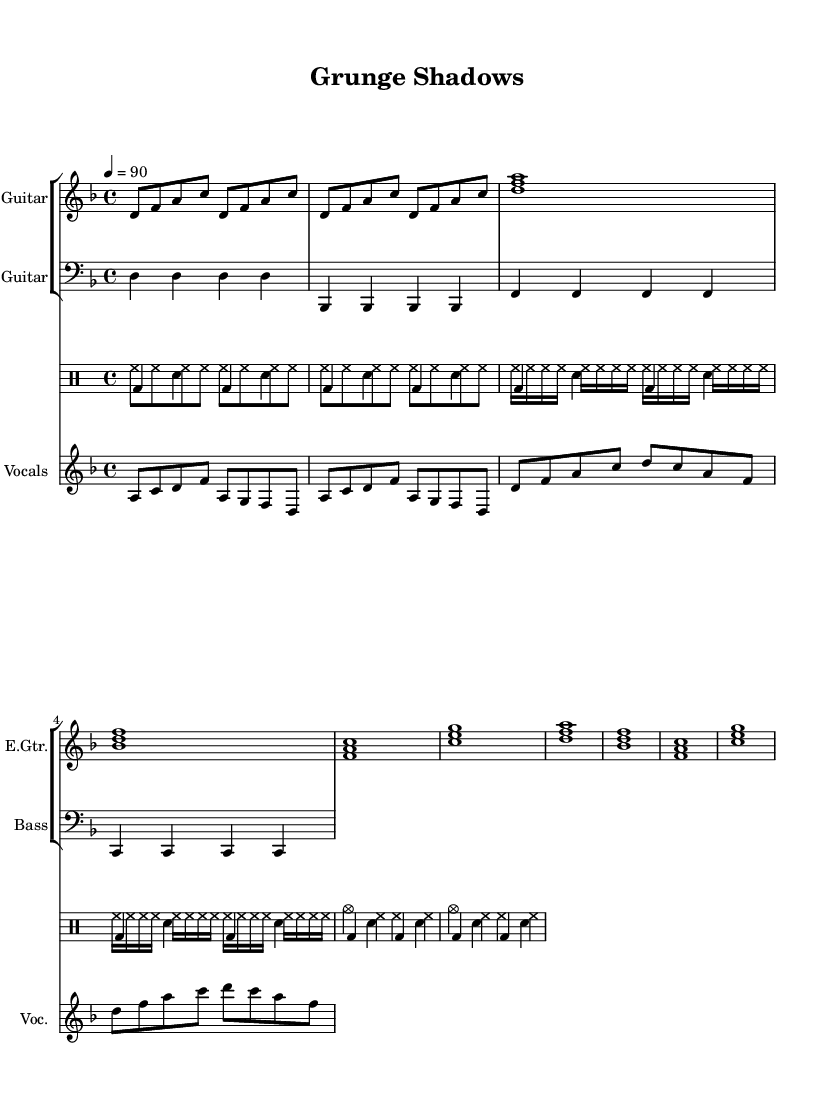What is the key signature of this music? The key signature indicates D minor, which has one flat (B flat). This can be identified at the beginning of the sheet music, where the key signature is notated.
Answer: D minor What is the time signature of this music? The time signature is 4/4, which is evident at the beginning of the score where the '4/4' is marked. This means there are four beats in a measure and a quarter note receives one beat.
Answer: 4/4 What is the tempo marking of this piece? The tempo marking is indicated as "4 = 90", meaning that the quarter note gets 90 beats per minute. This can be found near the beginning of the music under the global definitions.
Answer: 90 How many measures are in the verse section? To determine the number of measures in the verse, we count the measures specifically notated for the verse section in the score. There are a total of four measures designated for the verse.
Answer: 4 What drum pattern is used in the chorus? The drum pattern in the chorus features a bass drum followed by a snare drum. Each line of the chorus in the drum section indicates the standard beat sequence shared in hip-hop. Notably, the pattern is written as bass drum and snare alternating.
Answer: Bass and snare How does the vocal melody begin? The vocal melody begins on the note A and follows a specific rhythmic pattern introduced in the verse section. Looking at the vocal line, it starts with the notes a, c, d, f.
Answer: A What is the primary instrument featured in this sheet music? The primary instrument featured in the music is the Electric Guitar, which is indicated rightly at the top of the staff where it specifies "Electric Guitar." This instrument drives the melodic structure, important in the grunge-inspired beats.
Answer: Electric Guitar 